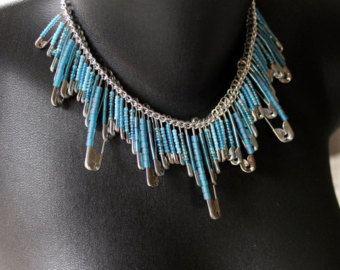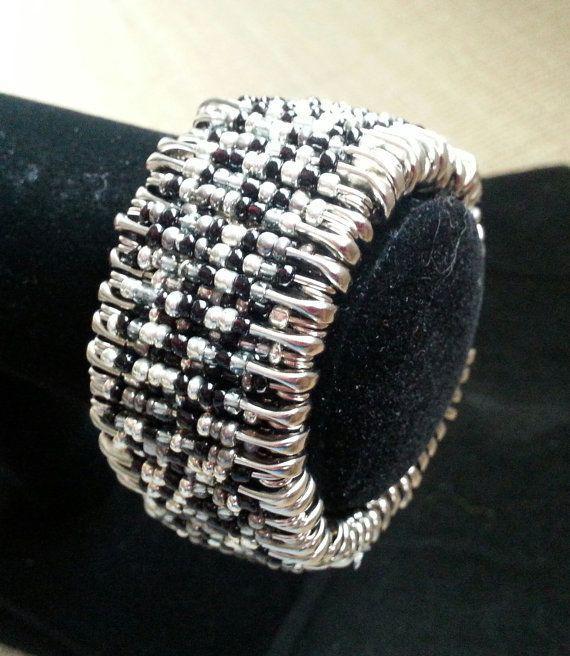The first image is the image on the left, the second image is the image on the right. Evaluate the accuracy of this statement regarding the images: "An image shows an item made of pins displayed around the neck of something.". Is it true? Answer yes or no. Yes. The first image is the image on the left, the second image is the image on the right. Analyze the images presented: Is the assertion "Two of the creations appear to be birds with outstretched wings." valid? Answer yes or no. No. 